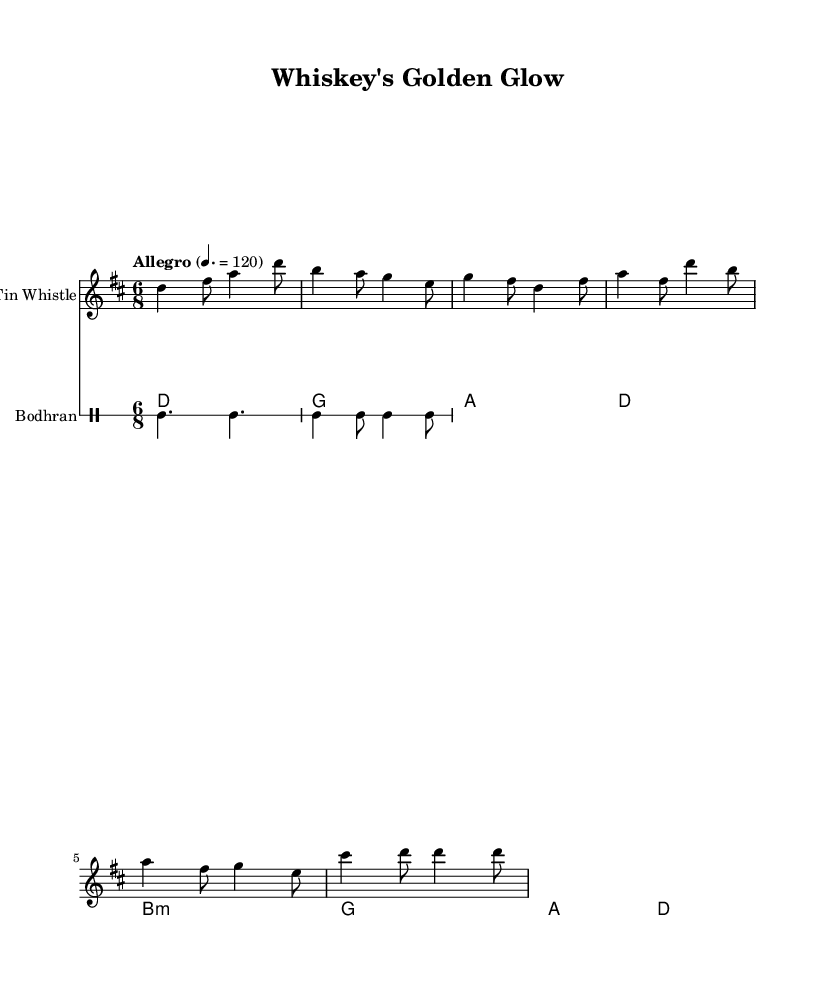What is the key signature of this music? The key signature is indicated at the beginning of the score. It shows two sharps, which corresponds to D major.
Answer: D major What is the time signature? The time signature is placed right after the key signature at the beginning of the score. It is 6/8, which indicates six eighth notes per measure.
Answer: 6/8 What is the tempo marking for the piece? The tempo marking appears at the beginning of the score and indicates the speed of the music. It shows "Allegro" with a metronome marking of 120 beats per minute.
Answer: Allegro How many measures are in the tin whistle part? To find the total number of measures, count the individual measures represented by the bar lines in the tin whistle part. There are six measures present in the score.
Answer: Six measures What type of percussion instrument is used in this music? The percussion instrument is indicated on the staff. The label shows "Bodhran," which is a traditional Irish frame drum used in Celtic music.
Answer: Bodhran What is the chord progression used by the celtic harp? The chord progression is identified in the chord mode section under the celtic harp. It goes from D to G to A to D and continues with B minor to G to A to D.
Answer: D, G, A, D, B minor, G, A, D Which section of the music is the dance rhythm characterized by? The dance rhythm is characterized by the rhythmic pattern used in the bodhran part, which shows a traditional drumming style for Celtic music, typically associated with a lively dance.
Answer: Bodhran rhythm 